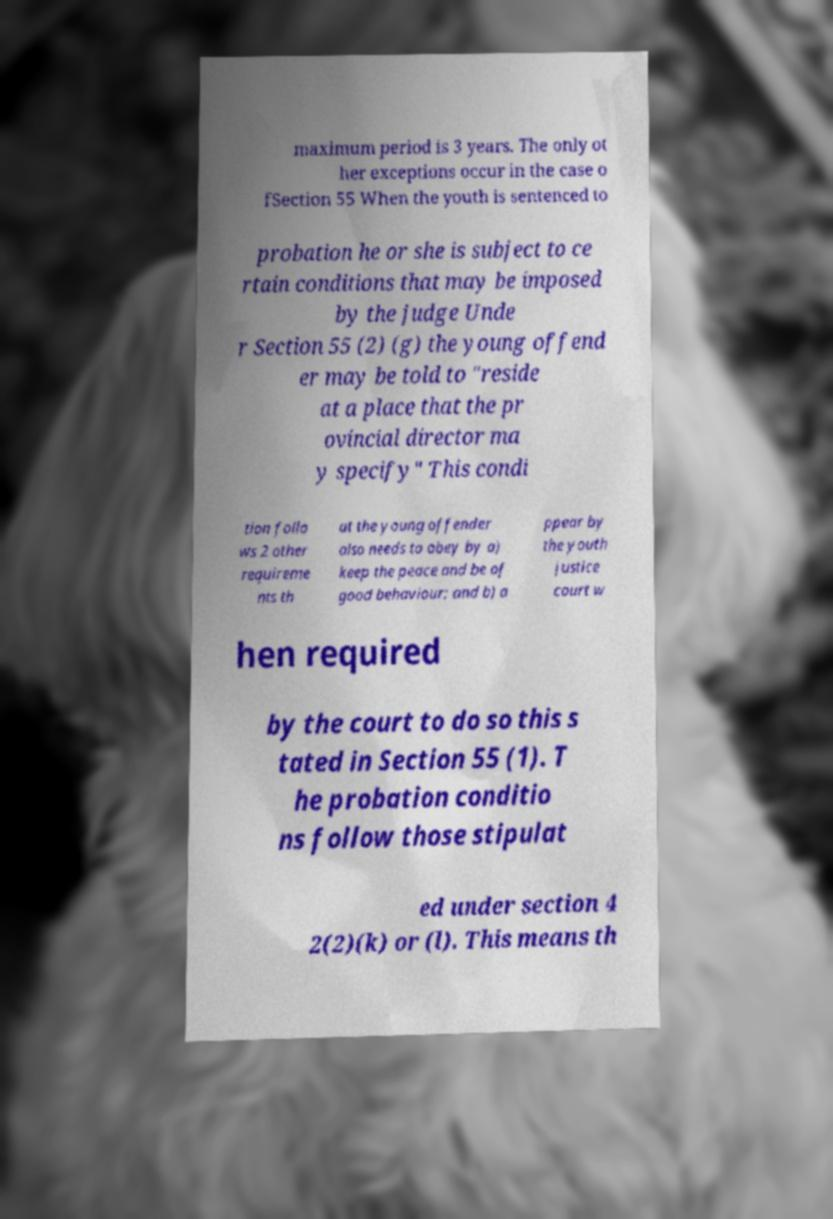There's text embedded in this image that I need extracted. Can you transcribe it verbatim? maximum period is 3 years. The only ot her exceptions occur in the case o fSection 55 When the youth is sentenced to probation he or she is subject to ce rtain conditions that may be imposed by the judge Unde r Section 55 (2) (g) the young offend er may be told to "reside at a place that the pr ovincial director ma y specify" This condi tion follo ws 2 other requireme nts th at the young offender also needs to obey by a) keep the peace and be of good behaviour; and b) a ppear by the youth justice court w hen required by the court to do so this s tated in Section 55 (1). T he probation conditio ns follow those stipulat ed under section 4 2(2)(k) or (l). This means th 